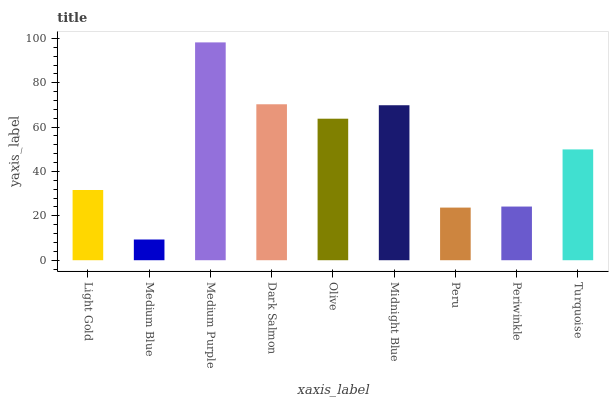Is Medium Blue the minimum?
Answer yes or no. Yes. Is Medium Purple the maximum?
Answer yes or no. Yes. Is Medium Purple the minimum?
Answer yes or no. No. Is Medium Blue the maximum?
Answer yes or no. No. Is Medium Purple greater than Medium Blue?
Answer yes or no. Yes. Is Medium Blue less than Medium Purple?
Answer yes or no. Yes. Is Medium Blue greater than Medium Purple?
Answer yes or no. No. Is Medium Purple less than Medium Blue?
Answer yes or no. No. Is Turquoise the high median?
Answer yes or no. Yes. Is Turquoise the low median?
Answer yes or no. Yes. Is Medium Purple the high median?
Answer yes or no. No. Is Dark Salmon the low median?
Answer yes or no. No. 